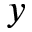Convert formula to latex. <formula><loc_0><loc_0><loc_500><loc_500>y</formula> 